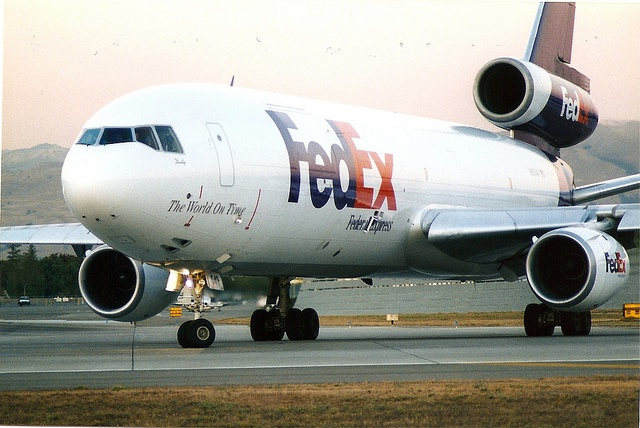Describe the objects in this image and their specific colors. I can see airplane in white, black, darkgray, and gray tones and car in white, black, purple, teal, and lightblue tones in this image. 